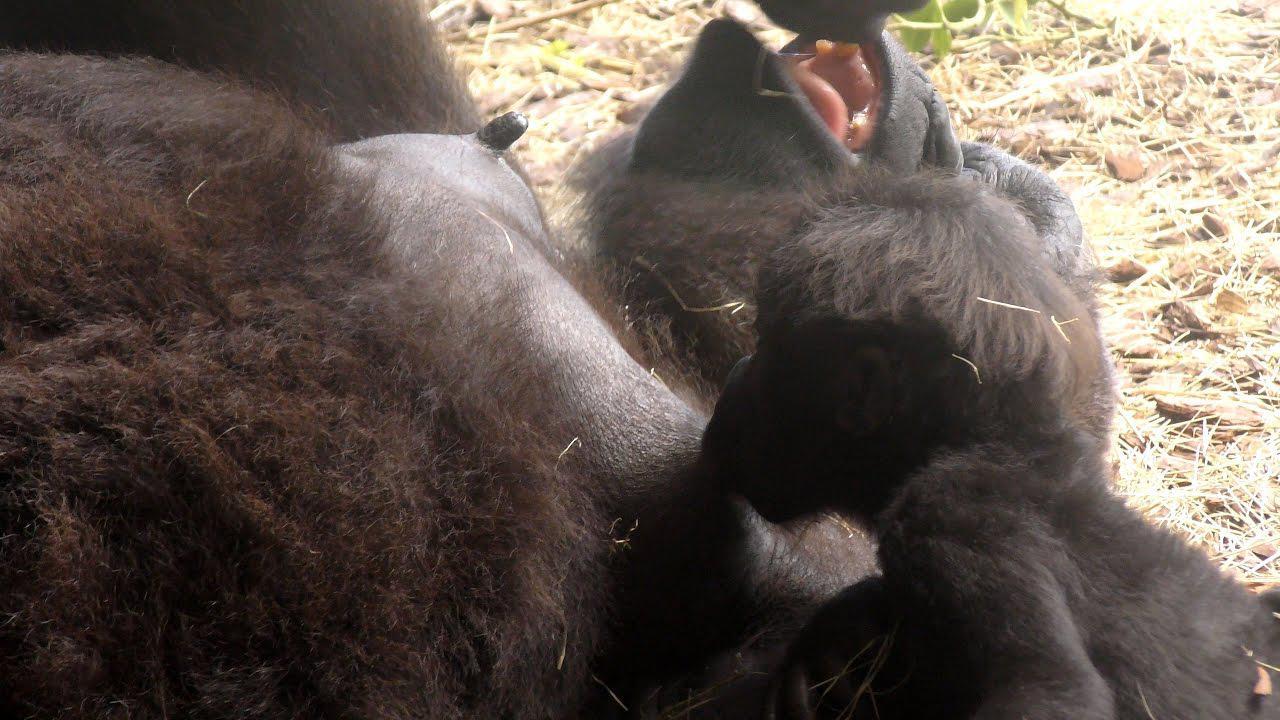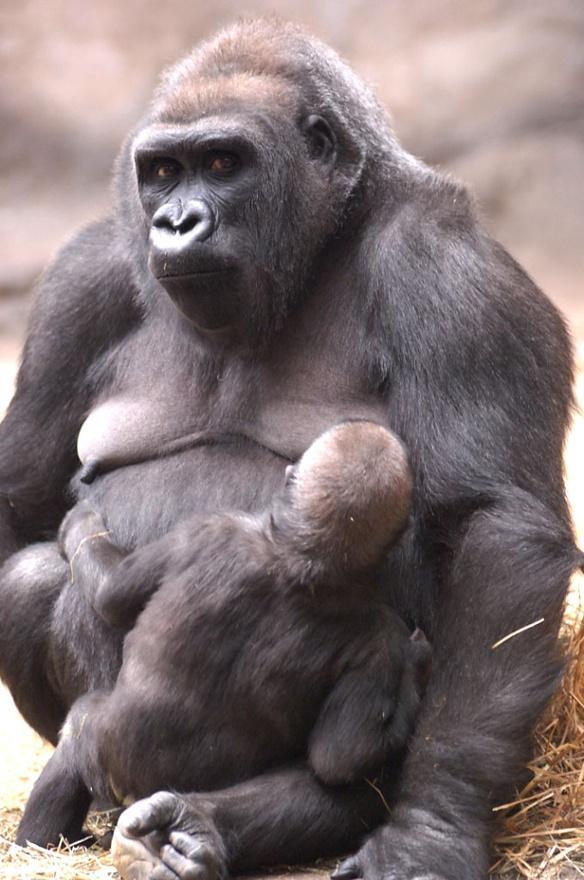The first image is the image on the left, the second image is the image on the right. For the images shown, is this caption "Each image shows a baby ape nursing at its mother's breast." true? Answer yes or no. Yes. The first image is the image on the left, the second image is the image on the right. Given the left and right images, does the statement "a gorilla is sitting in the grass holding her infant" hold true? Answer yes or no. No. 